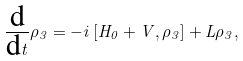<formula> <loc_0><loc_0><loc_500><loc_500>\frac { \text {d} } { \text {d} t } \rho _ { 3 } = - i \left [ H _ { 0 } + V , \rho _ { 3 } \right ] + L \rho _ { 3 } ,</formula> 